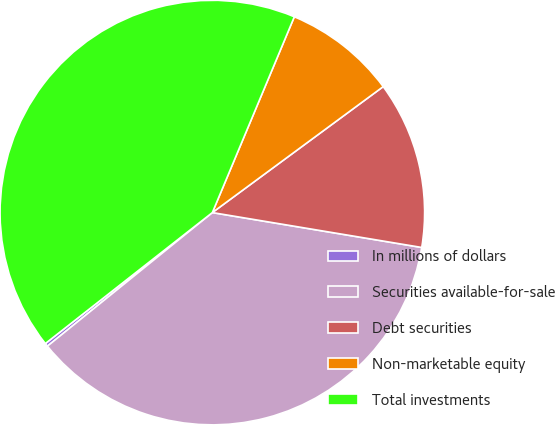<chart> <loc_0><loc_0><loc_500><loc_500><pie_chart><fcel>In millions of dollars<fcel>Securities available-for-sale<fcel>Debt securities<fcel>Non-marketable equity<fcel>Total investments<nl><fcel>0.25%<fcel>36.54%<fcel>12.74%<fcel>8.58%<fcel>41.9%<nl></chart> 